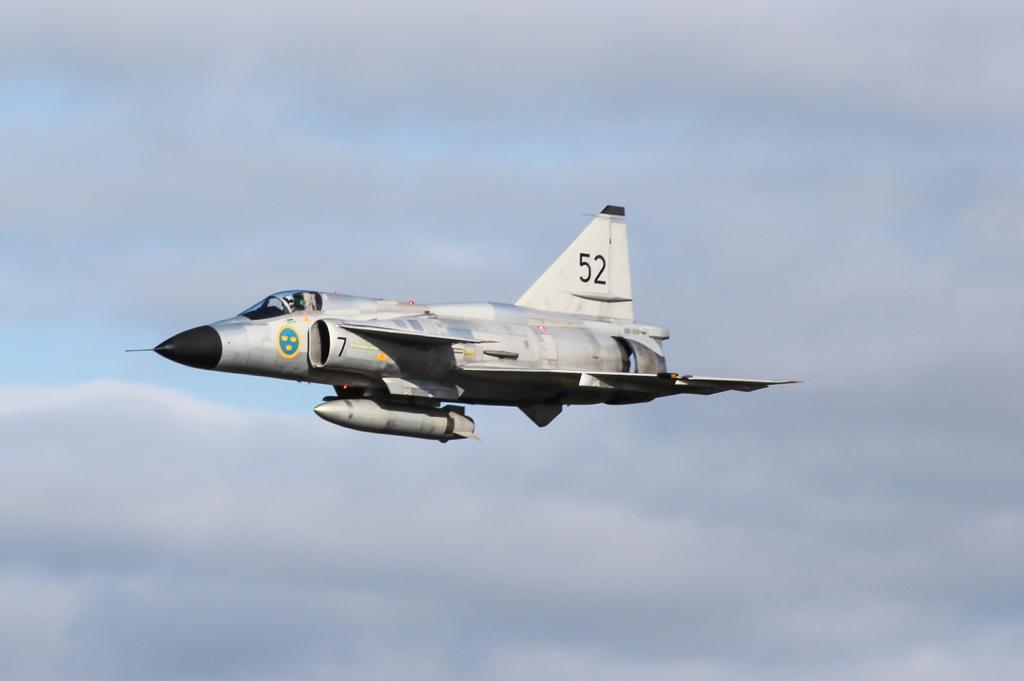Provide a one-sentence caption for the provided image. A fighter jet in mid flight with a black nose and the number fifty two on the tail wing. 